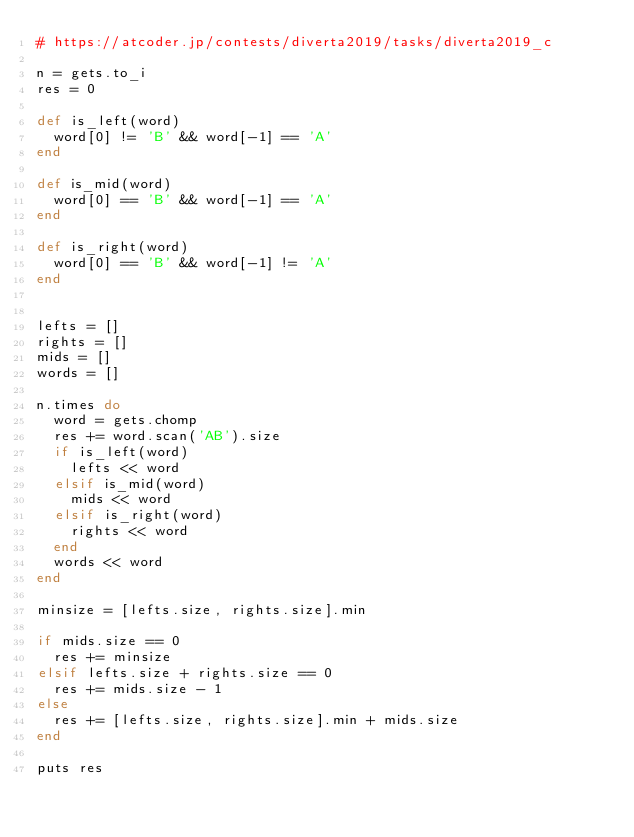Convert code to text. <code><loc_0><loc_0><loc_500><loc_500><_Ruby_># https://atcoder.jp/contests/diverta2019/tasks/diverta2019_c

n = gets.to_i
res = 0

def is_left(word)
  word[0] != 'B' && word[-1] == 'A'
end

def is_mid(word)
  word[0] == 'B' && word[-1] == 'A'
end

def is_right(word)
  word[0] == 'B' && word[-1] != 'A'
end


lefts = []
rights = []
mids = []
words = []

n.times do
  word = gets.chomp
  res += word.scan('AB').size
  if is_left(word)
    lefts << word
  elsif is_mid(word)
    mids << word
  elsif is_right(word)
    rights << word
  end
  words << word
end

minsize = [lefts.size, rights.size].min

if mids.size == 0
  res += minsize
elsif lefts.size + rights.size == 0
  res += mids.size - 1
else
  res += [lefts.size, rights.size].min + mids.size
end

puts res</code> 